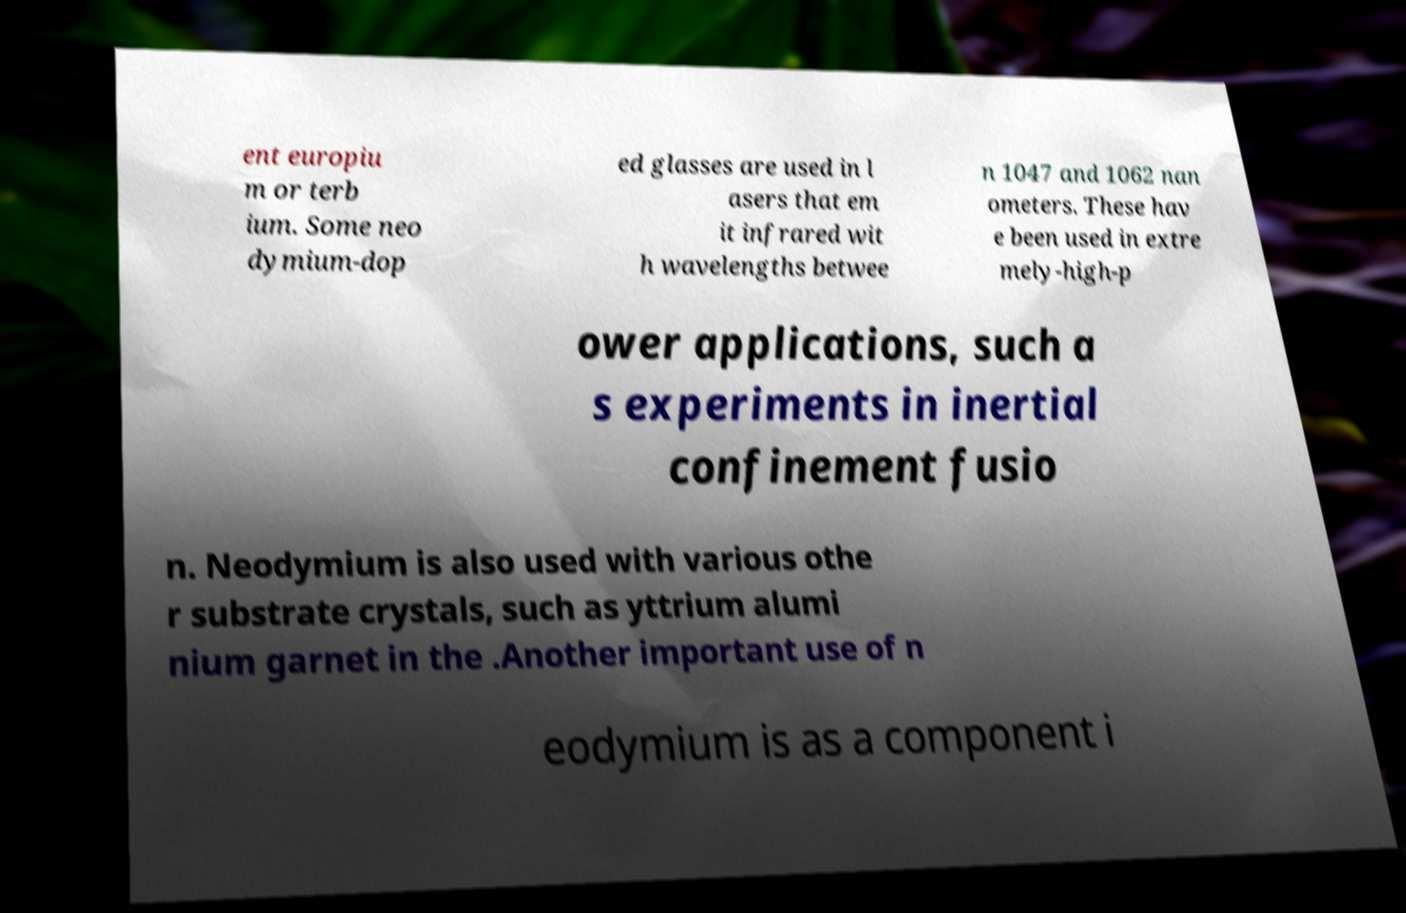For documentation purposes, I need the text within this image transcribed. Could you provide that? ent europiu m or terb ium. Some neo dymium-dop ed glasses are used in l asers that em it infrared wit h wavelengths betwee n 1047 and 1062 nan ometers. These hav e been used in extre mely-high-p ower applications, such a s experiments in inertial confinement fusio n. Neodymium is also used with various othe r substrate crystals, such as yttrium alumi nium garnet in the .Another important use of n eodymium is as a component i 